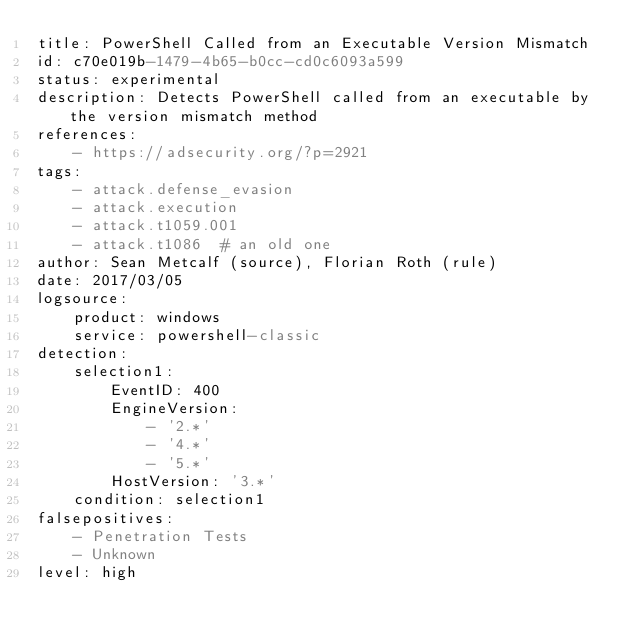Convert code to text. <code><loc_0><loc_0><loc_500><loc_500><_YAML_>title: PowerShell Called from an Executable Version Mismatch
id: c70e019b-1479-4b65-b0cc-cd0c6093a599
status: experimental
description: Detects PowerShell called from an executable by the version mismatch method
references:
    - https://adsecurity.org/?p=2921
tags:
    - attack.defense_evasion
    - attack.execution
    - attack.t1059.001
    - attack.t1086  # an old one
author: Sean Metcalf (source), Florian Roth (rule)
date: 2017/03/05
logsource:
    product: windows
    service: powershell-classic
detection:
    selection1:
        EventID: 400
        EngineVersion:
            - '2.*'
            - '4.*'
            - '5.*'
        HostVersion: '3.*'
    condition: selection1
falsepositives:
    - Penetration Tests
    - Unknown
level: high
</code> 